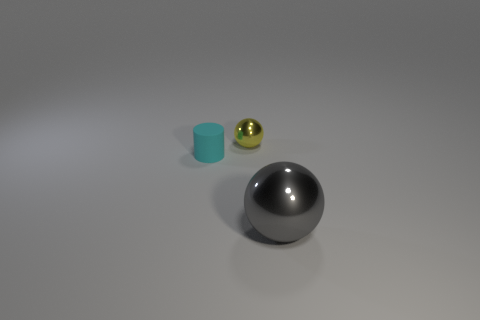Add 3 small cyan cylinders. How many objects exist? 6 Subtract all cylinders. How many objects are left? 2 Subtract 0 blue cylinders. How many objects are left? 3 Subtract all yellow things. Subtract all gray shiny balls. How many objects are left? 1 Add 1 cyan objects. How many cyan objects are left? 2 Add 2 large blue shiny cylinders. How many large blue shiny cylinders exist? 2 